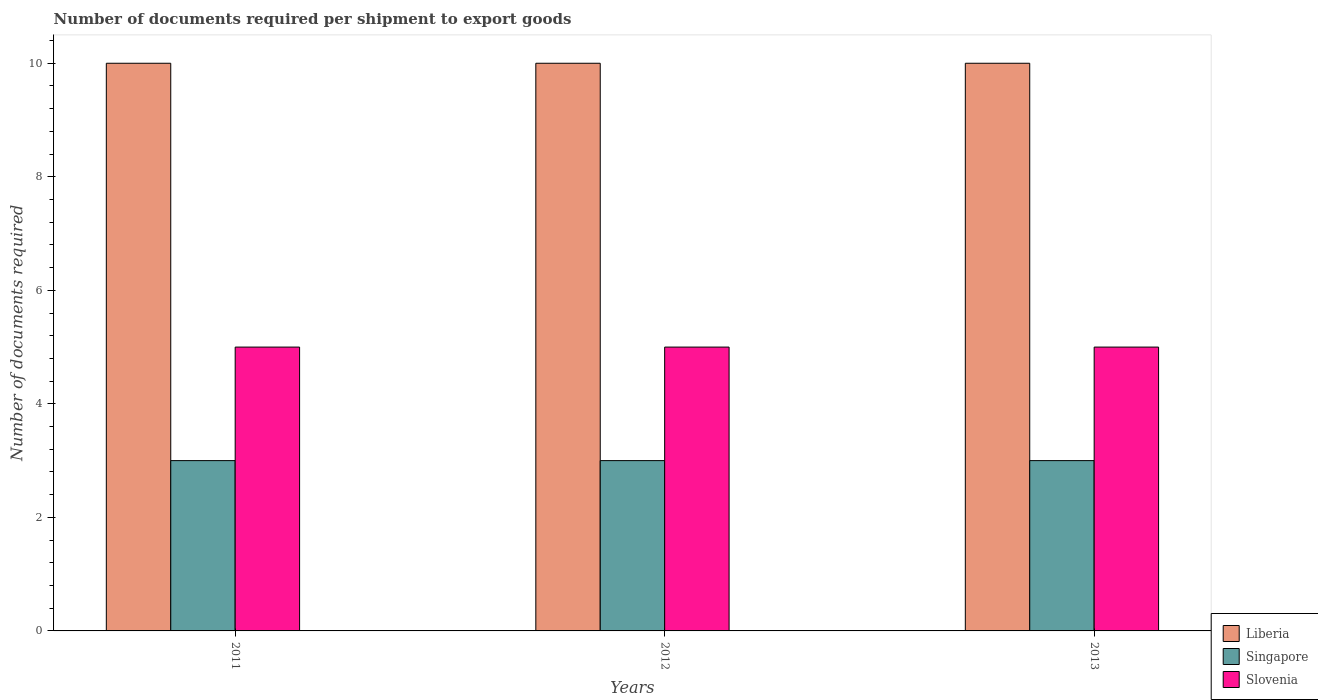Are the number of bars per tick equal to the number of legend labels?
Ensure brevity in your answer.  Yes. Are the number of bars on each tick of the X-axis equal?
Ensure brevity in your answer.  Yes. How many bars are there on the 2nd tick from the left?
Provide a short and direct response. 3. How many bars are there on the 3rd tick from the right?
Provide a short and direct response. 3. What is the label of the 3rd group of bars from the left?
Offer a very short reply. 2013. What is the number of documents required per shipment to export goods in Singapore in 2013?
Give a very brief answer. 3. Across all years, what is the maximum number of documents required per shipment to export goods in Slovenia?
Provide a short and direct response. 5. Across all years, what is the minimum number of documents required per shipment to export goods in Singapore?
Ensure brevity in your answer.  3. In which year was the number of documents required per shipment to export goods in Singapore maximum?
Ensure brevity in your answer.  2011. What is the total number of documents required per shipment to export goods in Slovenia in the graph?
Offer a very short reply. 15. In the year 2011, what is the difference between the number of documents required per shipment to export goods in Singapore and number of documents required per shipment to export goods in Slovenia?
Your response must be concise. -2. What is the ratio of the number of documents required per shipment to export goods in Liberia in 2011 to that in 2012?
Provide a short and direct response. 1. Is the difference between the number of documents required per shipment to export goods in Singapore in 2012 and 2013 greater than the difference between the number of documents required per shipment to export goods in Slovenia in 2012 and 2013?
Provide a short and direct response. No. What is the difference between the highest and the lowest number of documents required per shipment to export goods in Singapore?
Your answer should be compact. 0. Is the sum of the number of documents required per shipment to export goods in Slovenia in 2011 and 2012 greater than the maximum number of documents required per shipment to export goods in Singapore across all years?
Ensure brevity in your answer.  Yes. What does the 3rd bar from the left in 2013 represents?
Your answer should be very brief. Slovenia. What does the 1st bar from the right in 2012 represents?
Offer a terse response. Slovenia. Is it the case that in every year, the sum of the number of documents required per shipment to export goods in Liberia and number of documents required per shipment to export goods in Singapore is greater than the number of documents required per shipment to export goods in Slovenia?
Provide a short and direct response. Yes. How many bars are there?
Give a very brief answer. 9. What is the difference between two consecutive major ticks on the Y-axis?
Ensure brevity in your answer.  2. Are the values on the major ticks of Y-axis written in scientific E-notation?
Ensure brevity in your answer.  No. Does the graph contain any zero values?
Your answer should be compact. No. How many legend labels are there?
Your response must be concise. 3. What is the title of the graph?
Make the answer very short. Number of documents required per shipment to export goods. What is the label or title of the Y-axis?
Your answer should be very brief. Number of documents required. What is the Number of documents required in Liberia in 2011?
Give a very brief answer. 10. What is the Number of documents required of Singapore in 2011?
Ensure brevity in your answer.  3. What is the Number of documents required in Liberia in 2012?
Ensure brevity in your answer.  10. What is the Number of documents required of Slovenia in 2013?
Provide a succinct answer. 5. Across all years, what is the maximum Number of documents required in Liberia?
Ensure brevity in your answer.  10. Across all years, what is the maximum Number of documents required in Singapore?
Keep it short and to the point. 3. Across all years, what is the maximum Number of documents required in Slovenia?
Keep it short and to the point. 5. Across all years, what is the minimum Number of documents required of Singapore?
Keep it short and to the point. 3. What is the total Number of documents required of Singapore in the graph?
Your answer should be compact. 9. What is the total Number of documents required in Slovenia in the graph?
Provide a succinct answer. 15. What is the difference between the Number of documents required in Singapore in 2011 and that in 2012?
Your response must be concise. 0. What is the difference between the Number of documents required of Slovenia in 2011 and that in 2013?
Offer a very short reply. 0. What is the difference between the Number of documents required in Slovenia in 2012 and that in 2013?
Your answer should be very brief. 0. What is the difference between the Number of documents required in Liberia in 2011 and the Number of documents required in Singapore in 2012?
Provide a short and direct response. 7. What is the difference between the Number of documents required in Liberia in 2011 and the Number of documents required in Slovenia in 2012?
Offer a very short reply. 5. What is the difference between the Number of documents required of Singapore in 2011 and the Number of documents required of Slovenia in 2013?
Your response must be concise. -2. What is the difference between the Number of documents required of Liberia in 2012 and the Number of documents required of Singapore in 2013?
Your response must be concise. 7. What is the difference between the Number of documents required of Liberia in 2012 and the Number of documents required of Slovenia in 2013?
Offer a terse response. 5. What is the average Number of documents required in Liberia per year?
Make the answer very short. 10. What is the average Number of documents required of Singapore per year?
Provide a succinct answer. 3. What is the average Number of documents required in Slovenia per year?
Make the answer very short. 5. In the year 2011, what is the difference between the Number of documents required of Liberia and Number of documents required of Singapore?
Keep it short and to the point. 7. In the year 2011, what is the difference between the Number of documents required of Liberia and Number of documents required of Slovenia?
Make the answer very short. 5. In the year 2011, what is the difference between the Number of documents required in Singapore and Number of documents required in Slovenia?
Ensure brevity in your answer.  -2. In the year 2012, what is the difference between the Number of documents required of Singapore and Number of documents required of Slovenia?
Offer a terse response. -2. In the year 2013, what is the difference between the Number of documents required in Singapore and Number of documents required in Slovenia?
Offer a very short reply. -2. What is the ratio of the Number of documents required of Singapore in 2011 to that in 2012?
Your response must be concise. 1. What is the ratio of the Number of documents required in Liberia in 2011 to that in 2013?
Provide a succinct answer. 1. What is the ratio of the Number of documents required in Singapore in 2011 to that in 2013?
Make the answer very short. 1. What is the ratio of the Number of documents required in Slovenia in 2011 to that in 2013?
Provide a succinct answer. 1. What is the ratio of the Number of documents required in Singapore in 2012 to that in 2013?
Your answer should be very brief. 1. What is the difference between the highest and the second highest Number of documents required of Liberia?
Offer a terse response. 0. What is the difference between the highest and the second highest Number of documents required of Slovenia?
Provide a succinct answer. 0. What is the difference between the highest and the lowest Number of documents required of Singapore?
Ensure brevity in your answer.  0. What is the difference between the highest and the lowest Number of documents required of Slovenia?
Keep it short and to the point. 0. 